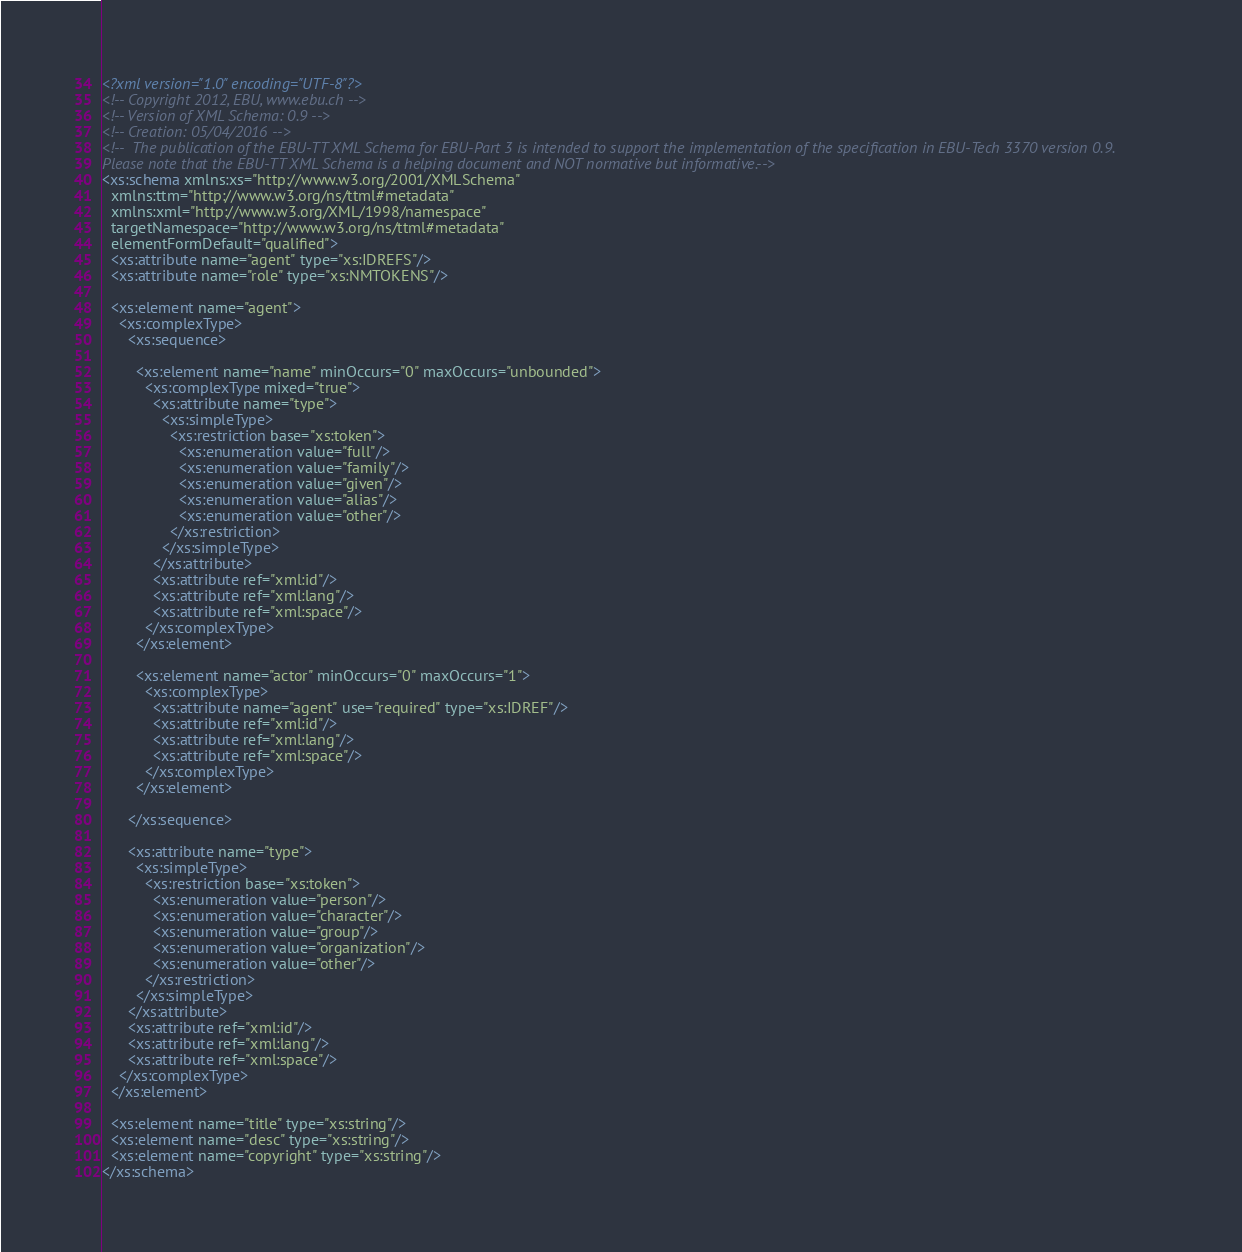Convert code to text. <code><loc_0><loc_0><loc_500><loc_500><_XML_><?xml version="1.0" encoding="UTF-8"?>
<!-- Copyright 2012, EBU, www.ebu.ch -->
<!-- Version of XML Schema: 0.9 -->
<!-- Creation: 05/04/2016 -->
<!--  The publication of the EBU-TT XML Schema for EBU-Part 3 is intended to support the implementation of the specification in EBU-Tech 3370 version 0.9.
Please note that the EBU-TT XML Schema is a helping document and NOT normative but informative.-->
<xs:schema xmlns:xs="http://www.w3.org/2001/XMLSchema"
  xmlns:ttm="http://www.w3.org/ns/ttml#metadata"
  xmlns:xml="http://www.w3.org/XML/1998/namespace"
  targetNamespace="http://www.w3.org/ns/ttml#metadata"
  elementFormDefault="qualified">
  <xs:attribute name="agent" type="xs:IDREFS"/>
  <xs:attribute name="role" type="xs:NMTOKENS"/>
  
  <xs:element name="agent">
    <xs:complexType>
      <xs:sequence>
        
        <xs:element name="name" minOccurs="0" maxOccurs="unbounded">
          <xs:complexType mixed="true">
            <xs:attribute name="type">
              <xs:simpleType>
                <xs:restriction base="xs:token">
                  <xs:enumeration value="full"/>
                  <xs:enumeration value="family"/>
                  <xs:enumeration value="given"/>
                  <xs:enumeration value="alias"/>
                  <xs:enumeration value="other"/>
                </xs:restriction>
              </xs:simpleType>
            </xs:attribute>
            <xs:attribute ref="xml:id"/>
            <xs:attribute ref="xml:lang"/>
            <xs:attribute ref="xml:space"/>
          </xs:complexType>
        </xs:element>
        
        <xs:element name="actor" minOccurs="0" maxOccurs="1">
          <xs:complexType>
            <xs:attribute name="agent" use="required" type="xs:IDREF"/>
            <xs:attribute ref="xml:id"/>
            <xs:attribute ref="xml:lang"/>
            <xs:attribute ref="xml:space"/>
          </xs:complexType>
        </xs:element>
        
      </xs:sequence>
      
      <xs:attribute name="type">
        <xs:simpleType>
          <xs:restriction base="xs:token">
            <xs:enumeration value="person"/>
            <xs:enumeration value="character"/>
            <xs:enumeration value="group"/>
            <xs:enumeration value="organization"/>
            <xs:enumeration value="other"/>
          </xs:restriction>
        </xs:simpleType>
      </xs:attribute>
      <xs:attribute ref="xml:id"/>
      <xs:attribute ref="xml:lang"/>
      <xs:attribute ref="xml:space"/>
    </xs:complexType>
  </xs:element>
  
  <xs:element name="title" type="xs:string"/>
  <xs:element name="desc" type="xs:string"/>
  <xs:element name="copyright" type="xs:string"/>
</xs:schema>
</code> 